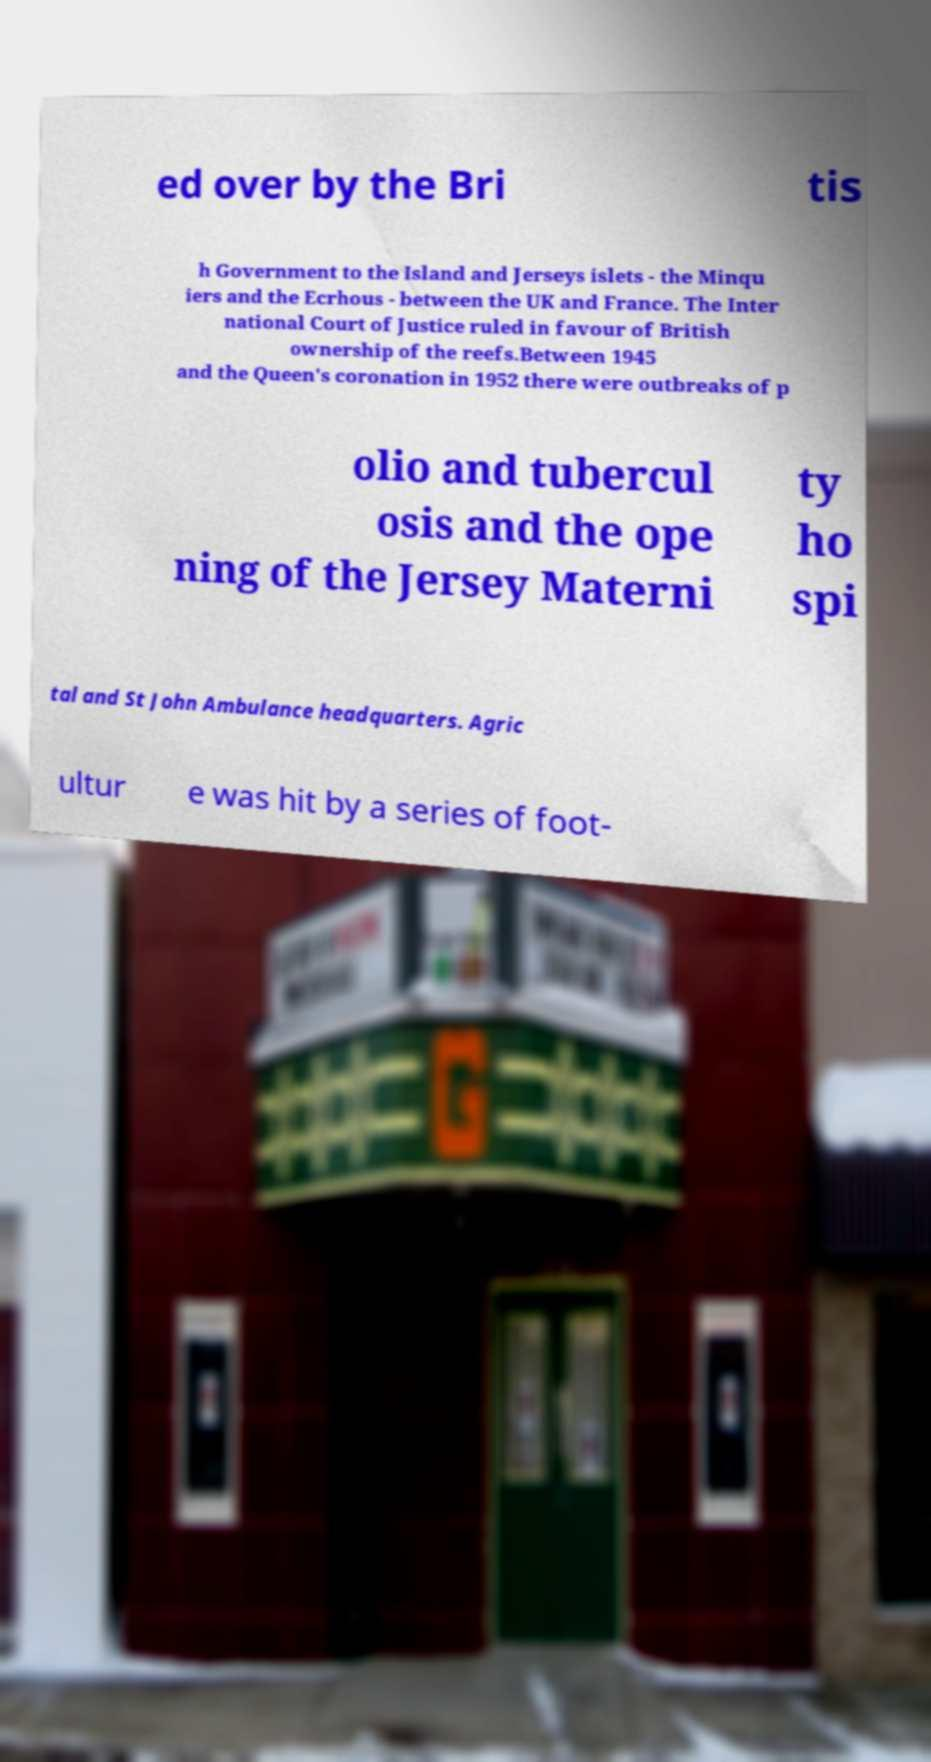Please identify and transcribe the text found in this image. ed over by the Bri tis h Government to the Island and Jerseys islets - the Minqu iers and the Ecrhous - between the UK and France. The Inter national Court of Justice ruled in favour of British ownership of the reefs.Between 1945 and the Queen's coronation in 1952 there were outbreaks of p olio and tubercul osis and the ope ning of the Jersey Materni ty ho spi tal and St John Ambulance headquarters. Agric ultur e was hit by a series of foot- 